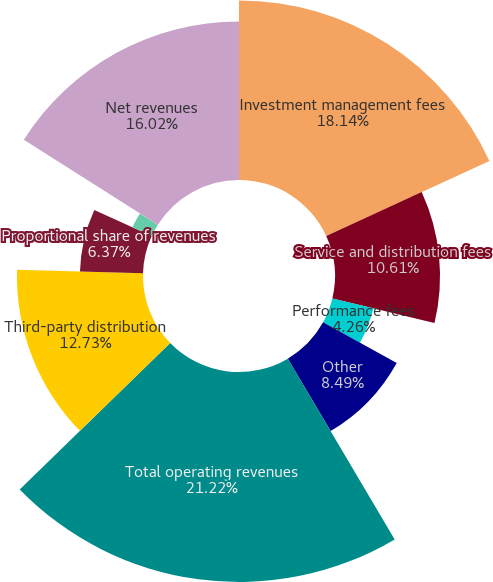Convert chart to OTSL. <chart><loc_0><loc_0><loc_500><loc_500><pie_chart><fcel>Investment management fees<fcel>Service and distribution fees<fcel>Performance fees<fcel>Other<fcel>Total operating revenues<fcel>Third-party distribution<fcel>Proportional share of revenues<fcel>Management fees earned from<fcel>Other revenues recorded by<fcel>Net revenues<nl><fcel>18.14%<fcel>10.61%<fcel>4.26%<fcel>8.49%<fcel>21.21%<fcel>12.73%<fcel>6.37%<fcel>2.14%<fcel>0.02%<fcel>16.02%<nl></chart> 